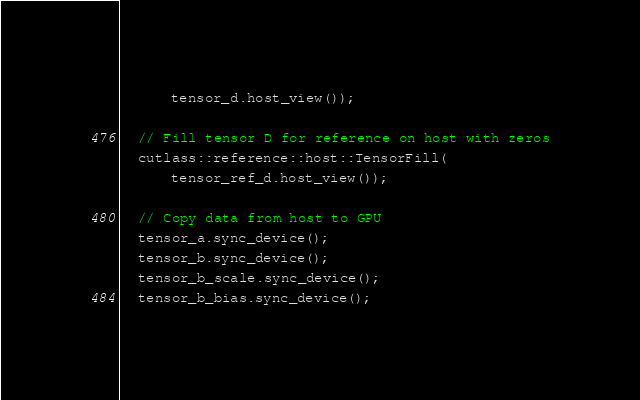Convert code to text. <code><loc_0><loc_0><loc_500><loc_500><_Cuda_>      tensor_d.host_view());

  // Fill tensor D for reference on host with zeros
  cutlass::reference::host::TensorFill(
      tensor_ref_d.host_view());

  // Copy data from host to GPU
  tensor_a.sync_device();
  tensor_b.sync_device();
  tensor_b_scale.sync_device();
  tensor_b_bias.sync_device();</code> 